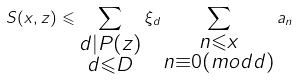<formula> <loc_0><loc_0><loc_500><loc_500>S ( x , z ) \leqslant \sum _ { \substack { d | P ( z ) \\ d \leqslant D } } \xi _ { d } \sum _ { \substack { n \leqslant x \\ n \equiv 0 ( m o d d ) } } a _ { n }</formula> 